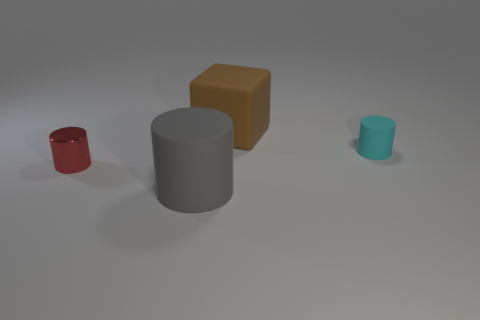Subtract all small cylinders. How many cylinders are left? 1 Add 3 metallic cylinders. How many objects exist? 7 Subtract 1 cylinders. How many cylinders are left? 2 Subtract all cylinders. How many objects are left? 1 Add 3 red shiny things. How many red shiny things are left? 4 Add 4 tiny shiny cylinders. How many tiny shiny cylinders exist? 5 Subtract 0 purple cubes. How many objects are left? 4 Subtract all big objects. Subtract all tiny brown matte cubes. How many objects are left? 2 